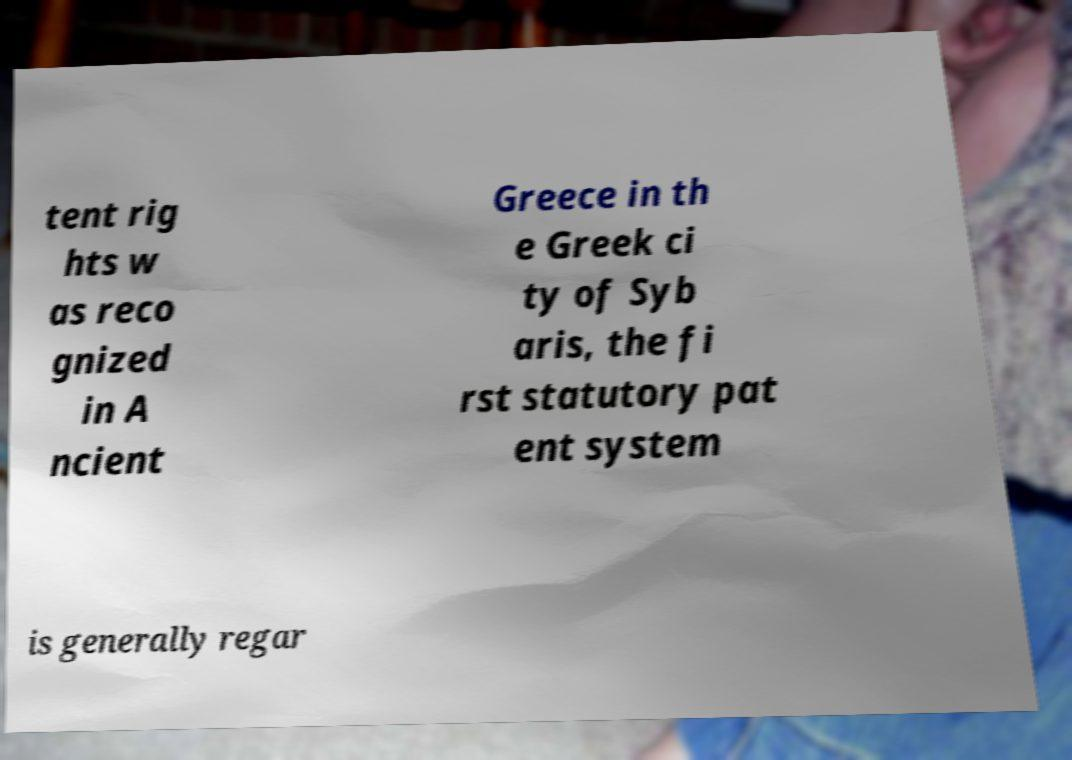Can you accurately transcribe the text from the provided image for me? tent rig hts w as reco gnized in A ncient Greece in th e Greek ci ty of Syb aris, the fi rst statutory pat ent system is generally regar 